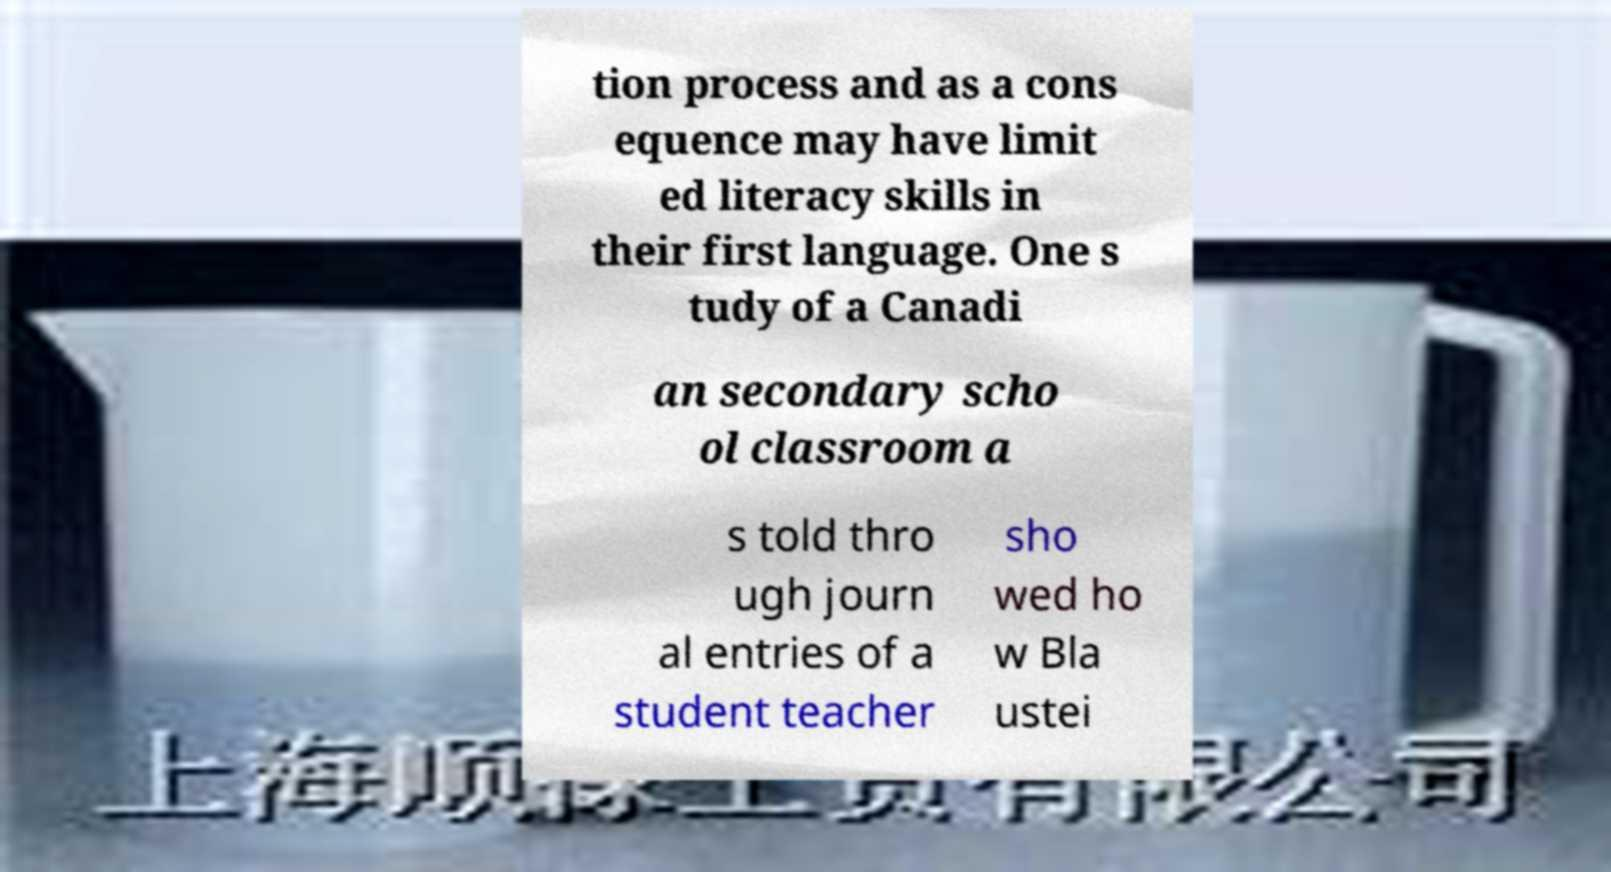Could you extract and type out the text from this image? tion process and as a cons equence may have limit ed literacy skills in their first language. One s tudy of a Canadi an secondary scho ol classroom a s told thro ugh journ al entries of a student teacher sho wed ho w Bla ustei 